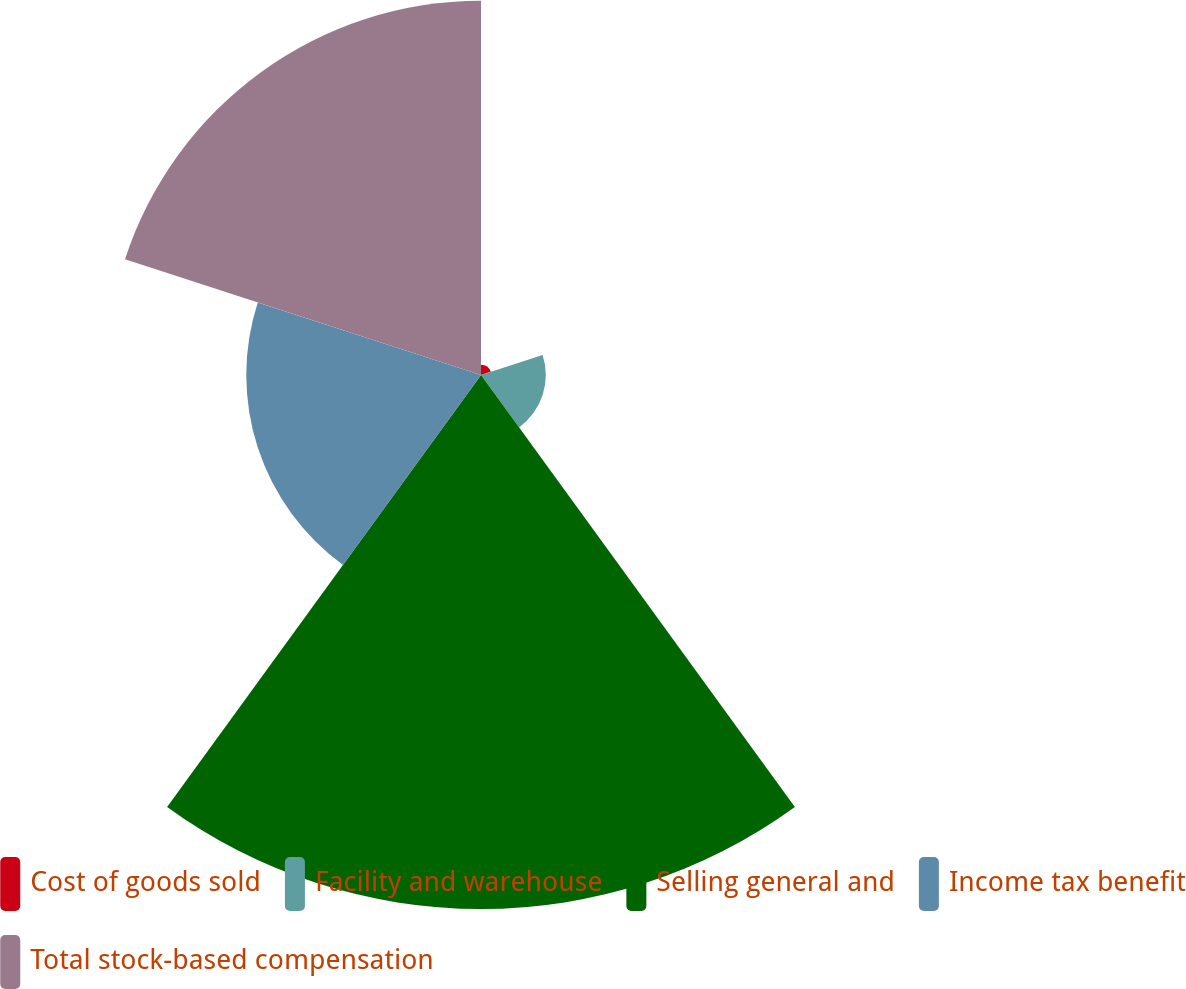Convert chart to OTSL. <chart><loc_0><loc_0><loc_500><loc_500><pie_chart><fcel>Cost of goods sold<fcel>Facility and warehouse<fcel>Selling general and<fcel>Income tax benefit<fcel>Total stock-based compensation<nl><fcel>0.84%<fcel>5.32%<fcel>43.84%<fcel>19.27%<fcel>30.73%<nl></chart> 